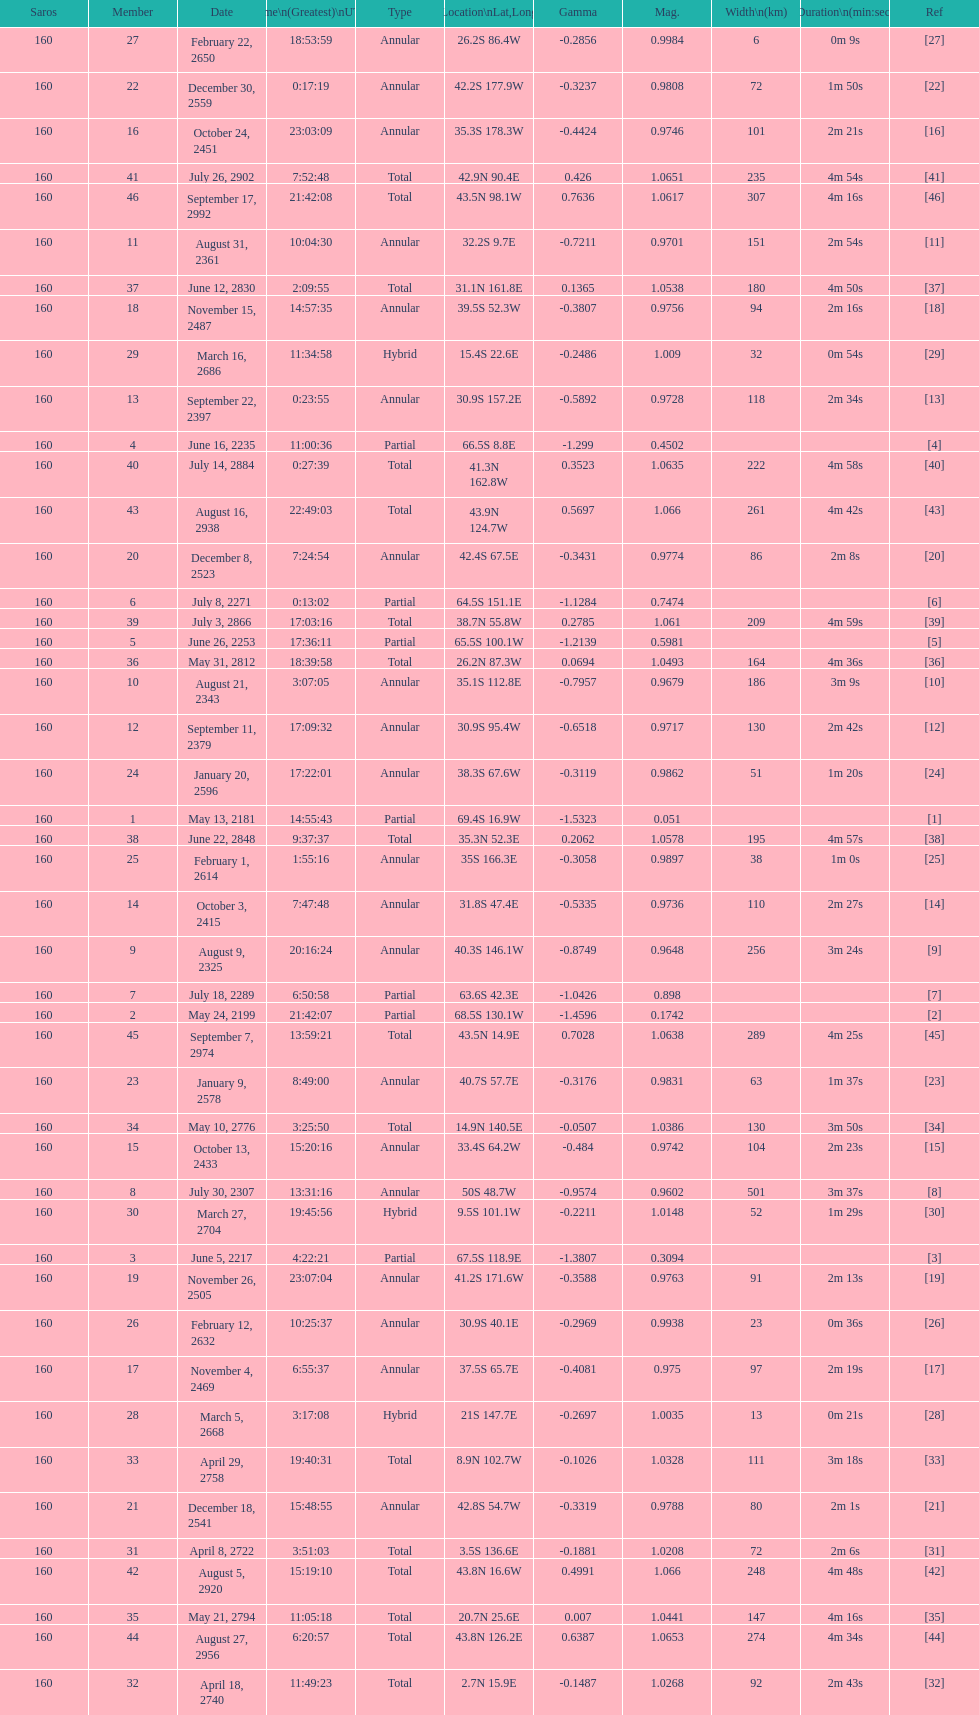Which one has a larger width, 8 or 21? 8. 